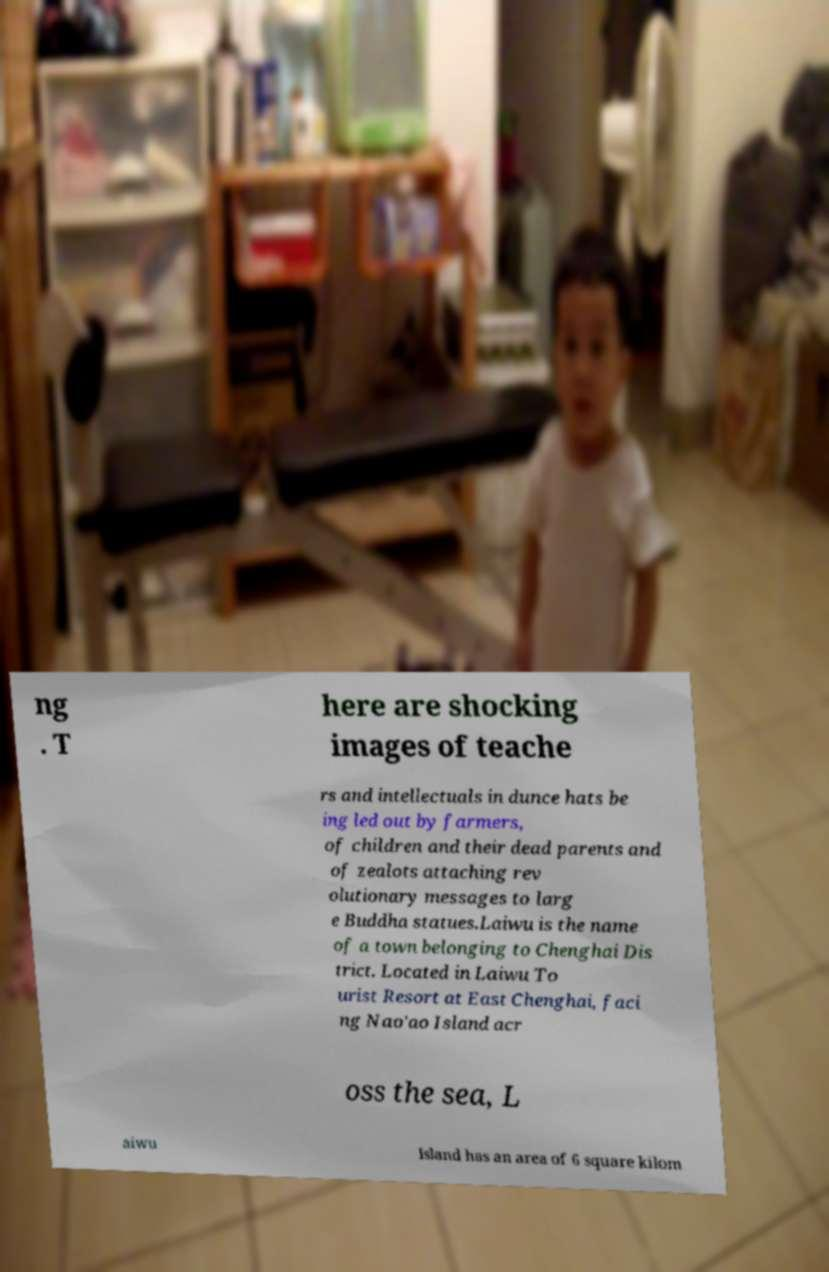Could you extract and type out the text from this image? ng . T here are shocking images of teache rs and intellectuals in dunce hats be ing led out by farmers, of children and their dead parents and of zealots attaching rev olutionary messages to larg e Buddha statues.Laiwu is the name of a town belonging to Chenghai Dis trict. Located in Laiwu To urist Resort at East Chenghai, faci ng Nao'ao Island acr oss the sea, L aiwu Island has an area of 6 square kilom 